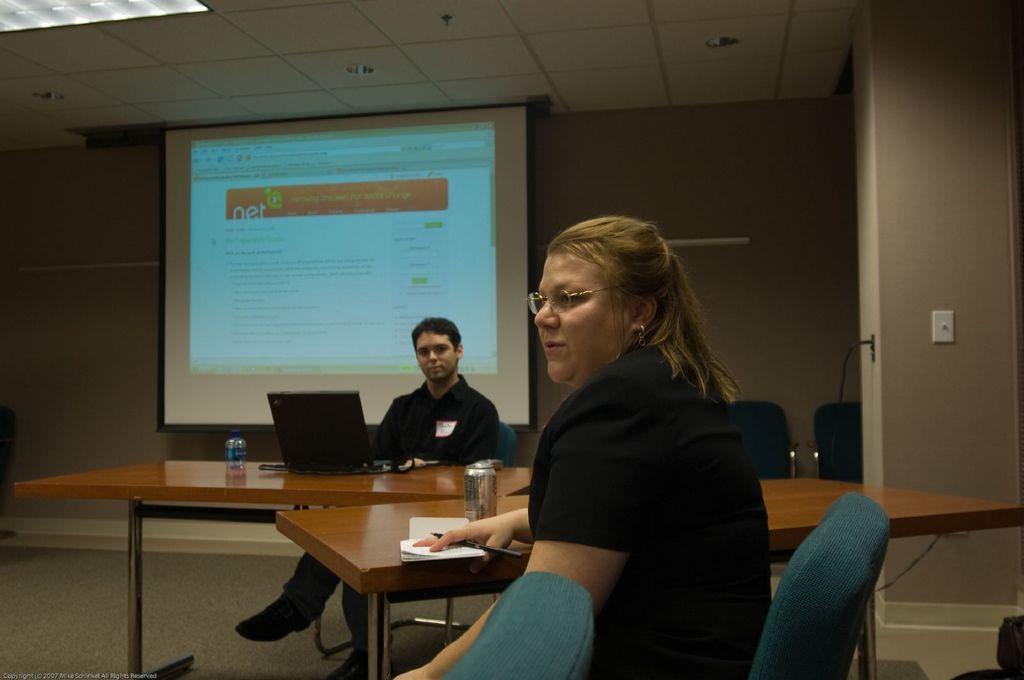In one or two sentences, can you explain what this image depicts? A lady wearing a specs and holding a pen and sitting on chair. Another person is sitting. There are tables. On the table there are laptops, bottles, papers and a can. In the background there is a screen, door, chairs, wall. 